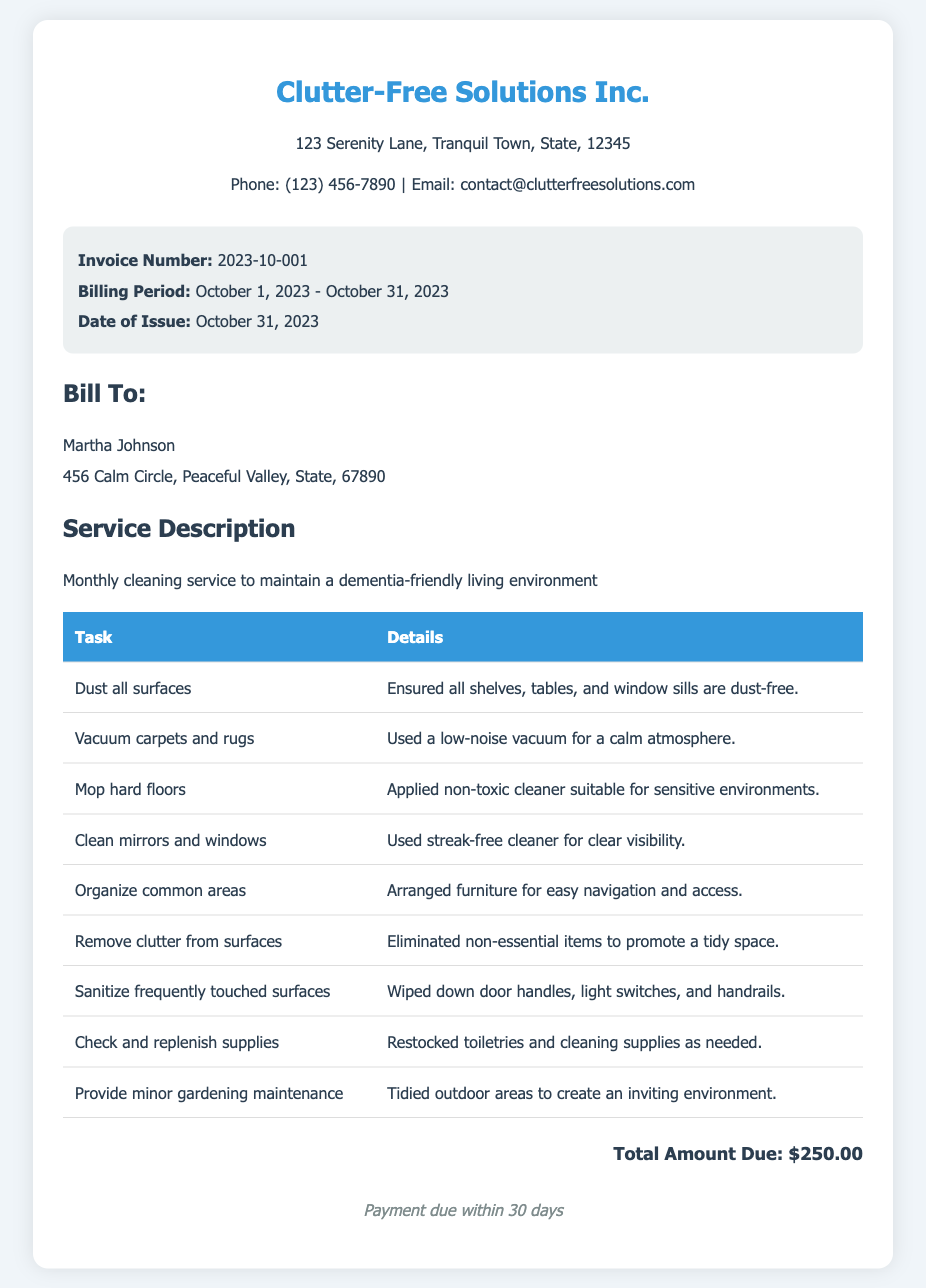What is the company name? The company name is listed at the top of the document.
Answer: Clutter-Free Solutions Inc What is the invoice number? The invoice number is identified in the invoice details section.
Answer: 2023-10-001 What is the billing period? The billing period is specified in the invoice details.
Answer: October 1, 2023 - October 31, 2023 Who is the bill addressed to? The client's name is mentioned in the client info section.
Answer: Martha Johnson What is the total amount due? The total amount due is mentioned towards the end of the document.
Answer: $250.00 How many tasks are listed in the service description? Counting the rows in the tasks table can reveal the total number of tasks provided.
Answer: 9 What type of environment is the cleaning service for? The service description specifies the type of living environment.
Answer: dementia-friendly What is the payment term? The payment terms are stated in the document's footer.
Answer: Payment due within 30 days What type of cleaner was used for mopping hard floors? The details of the mopping task include information about the cleaner type.
Answer: non-toxic cleaner 